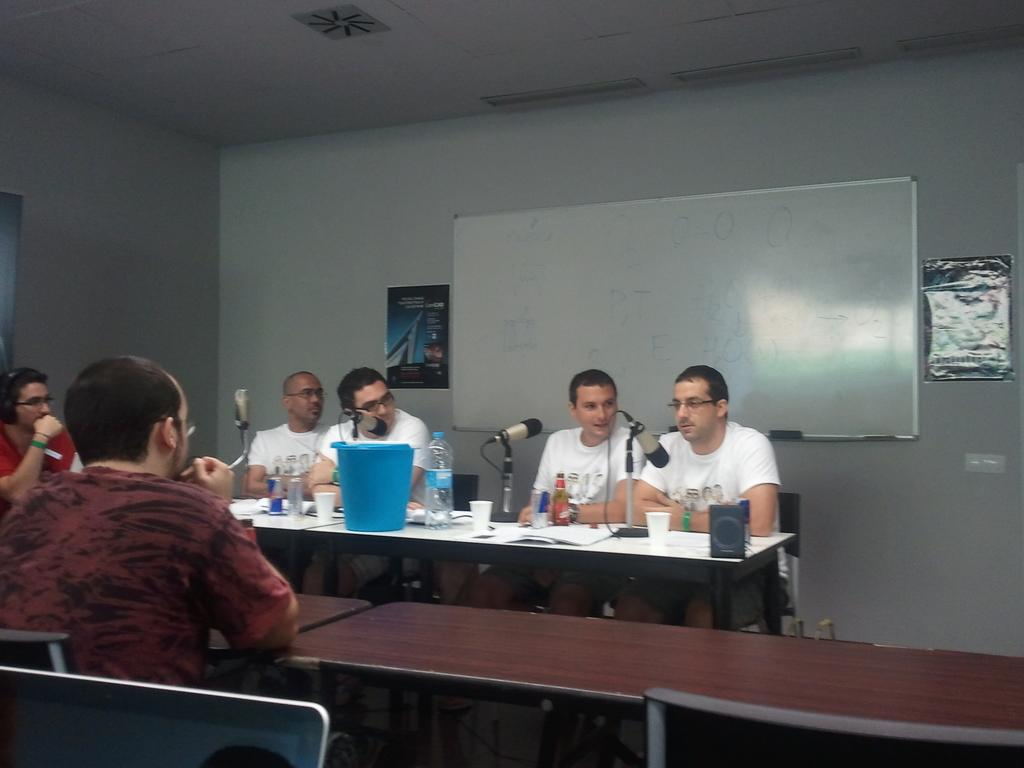How many men are present in the image? There are 6 men in the image. What is in front of the men? There are tables in front of the men. What can be found on the tables? There are multiple objects on the tables. What can be seen in the background of the image? There is a wall and a board in the background of the image. How many posters are on the wall in the background? There are 2 posters on the wall in the background. What type of oranges are being used as decorations on the men's hair in the image? There are no oranges or any decorations on the men's hair in the image. How does the laughter of the men affect the overall mood of the image? There is no mention of laughter or any emotional state in the image. 